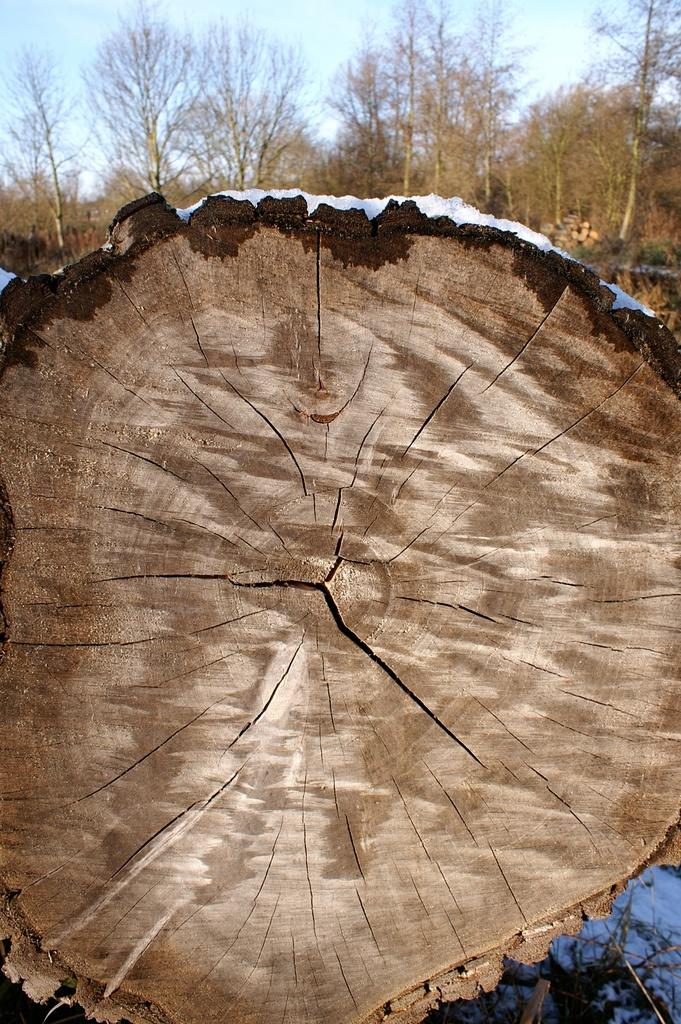What is the main object in the image that has snow on it? There is a wooden log with snow on it in the image. What other objects can be seen in the image? Sticks are visible in the image. What is the condition of the ground in the image? Snow is present on the ground. What can be seen in the background of the image? Trees and the sky are visible in the background of the image. What color of paint is being used to decorate the shelf in the image? There is no shelf present in the image, and therefore no paint or decoration can be observed. 